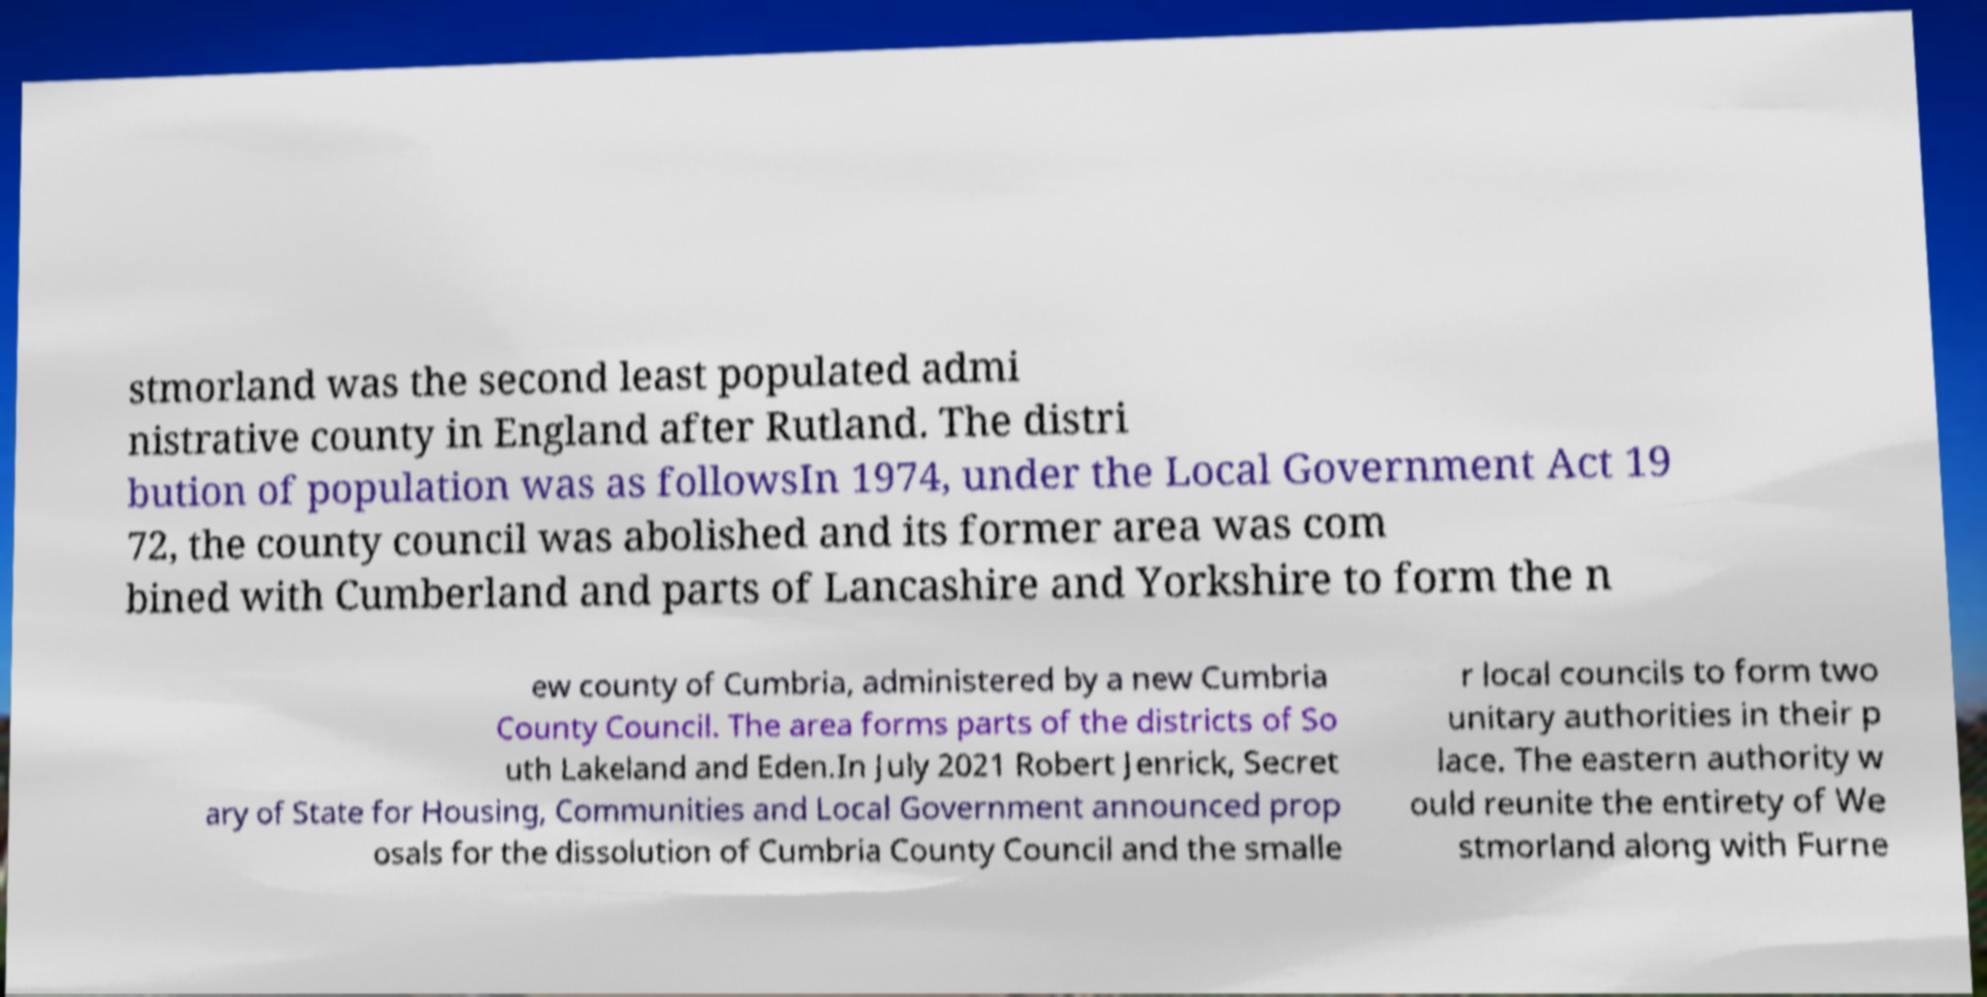I need the written content from this picture converted into text. Can you do that? stmorland was the second least populated admi nistrative county in England after Rutland. The distri bution of population was as followsIn 1974, under the Local Government Act 19 72, the county council was abolished and its former area was com bined with Cumberland and parts of Lancashire and Yorkshire to form the n ew county of Cumbria, administered by a new Cumbria County Council. The area forms parts of the districts of So uth Lakeland and Eden.In July 2021 Robert Jenrick, Secret ary of State for Housing, Communities and Local Government announced prop osals for the dissolution of Cumbria County Council and the smalle r local councils to form two unitary authorities in their p lace. The eastern authority w ould reunite the entirety of We stmorland along with Furne 